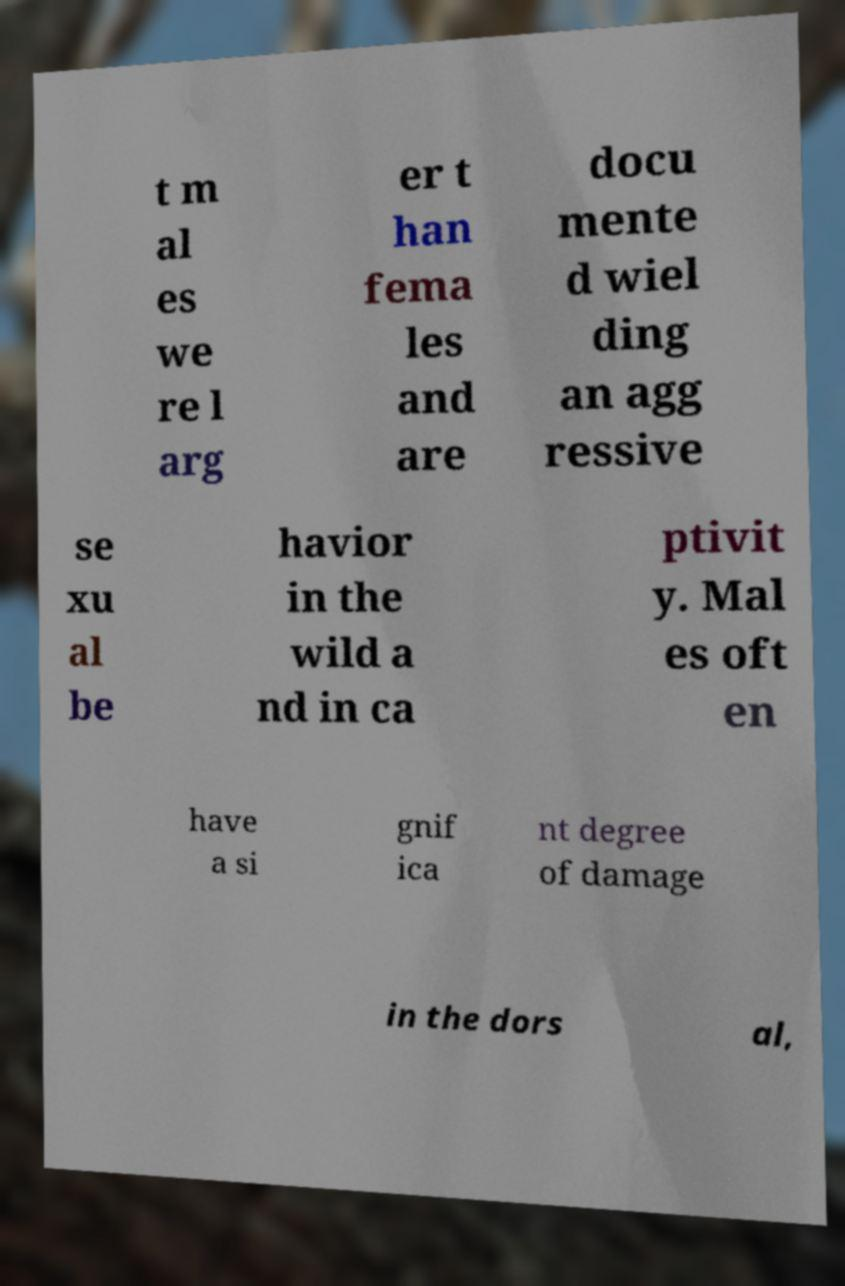What messages or text are displayed in this image? I need them in a readable, typed format. t m al es we re l arg er t han fema les and are docu mente d wiel ding an agg ressive se xu al be havior in the wild a nd in ca ptivit y. Mal es oft en have a si gnif ica nt degree of damage in the dors al, 